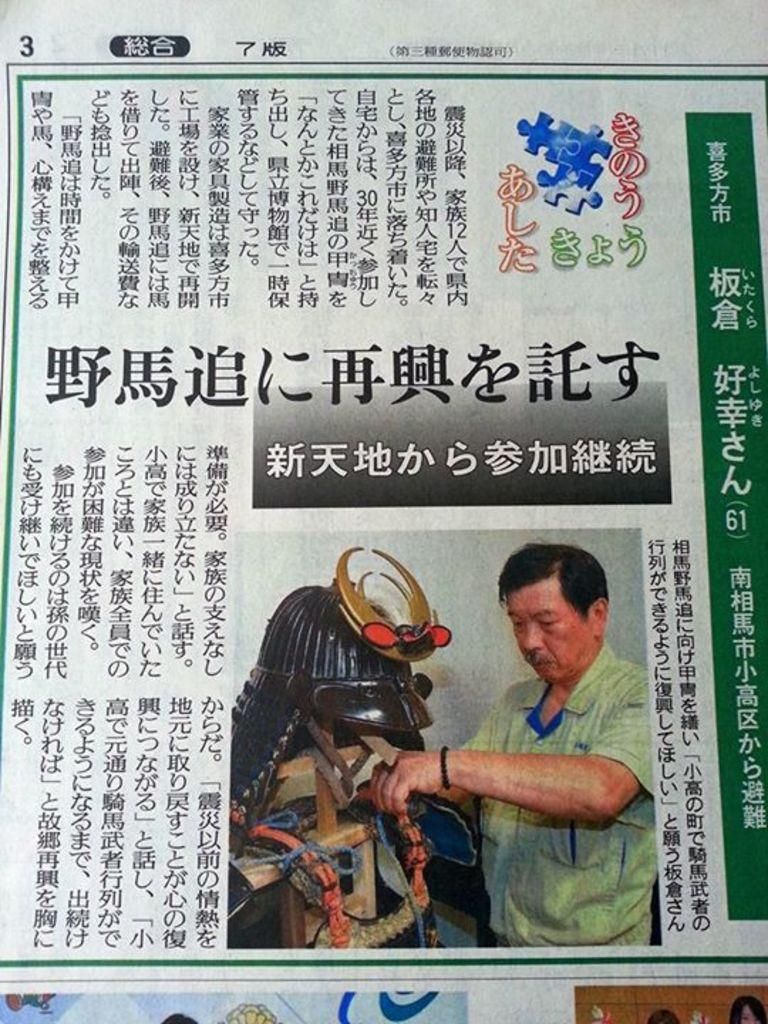What is present in the image? There is a poster in the image. What can be seen on the poster? There is writing in different languages on the poster. Can you describe the image on the poster? There is a man on the right side of the poster. How many ladybugs are crawling on the poster in the image? There are no ladybugs present on the poster in the image. What type of trade is being conducted in the image? There is no trade being conducted in the image; it features a poster with writing in different languages and an image of a man. 